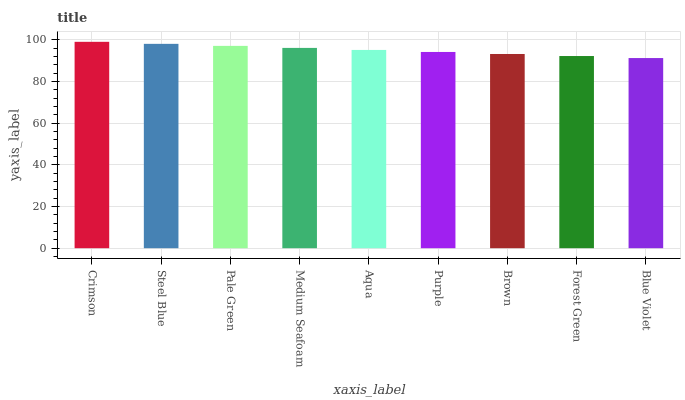Is Blue Violet the minimum?
Answer yes or no. Yes. Is Crimson the maximum?
Answer yes or no. Yes. Is Steel Blue the minimum?
Answer yes or no. No. Is Steel Blue the maximum?
Answer yes or no. No. Is Crimson greater than Steel Blue?
Answer yes or no. Yes. Is Steel Blue less than Crimson?
Answer yes or no. Yes. Is Steel Blue greater than Crimson?
Answer yes or no. No. Is Crimson less than Steel Blue?
Answer yes or no. No. Is Aqua the high median?
Answer yes or no. Yes. Is Aqua the low median?
Answer yes or no. Yes. Is Forest Green the high median?
Answer yes or no. No. Is Blue Violet the low median?
Answer yes or no. No. 